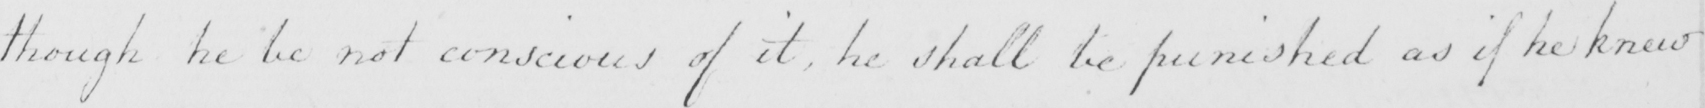Please provide the text content of this handwritten line. though he be not conscious of it , he shall be punished as if he knew 